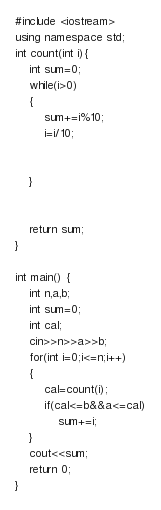Convert code to text. <code><loc_0><loc_0><loc_500><loc_500><_C++_>#include <iostream>
using namespace std;
int count(int i){
    int sum=0;
    while(i>0)
    {
        sum+=i%10;
        i=i/10;
        
        
    }
    
    
    return sum;
}
 
int main() {
    int n,a,b;
    int sum=0;
    int cal;
    cin>>n>>a>>b;
    for(int i=0;i<=n;i++)
    {
        cal=count(i);
        if(cal<=b&&a<=cal)
            sum+=i;
    }
    cout<<sum;
    return 0;
}</code> 